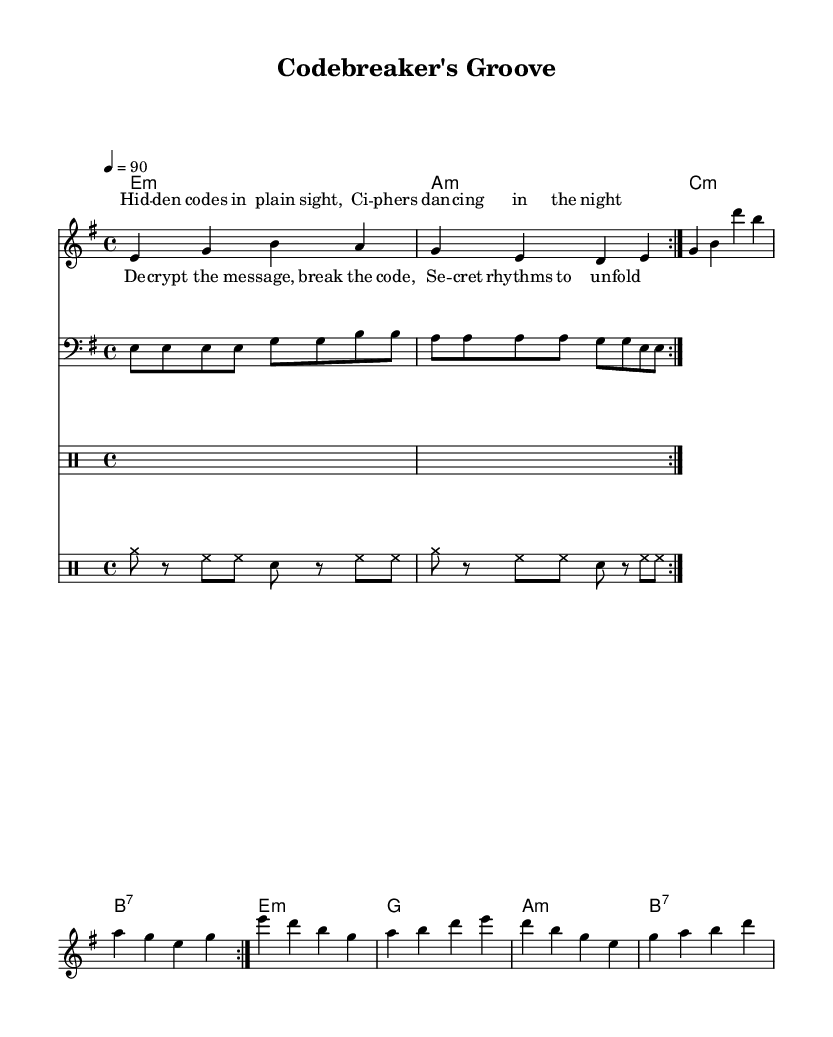What is the key signature of this music? The key signature is indicated at the beginning of the music, showing two sharps, which are F# and C#. This means the piece is in the key of E minor.
Answer: E minor What is the time signature of this music? The time signature is shown at the beginning of the music with a "4/4" notation, indicating that there are four beats in each measure and a quarter note receives one beat.
Answer: 4/4 What is the tempo marking of this music? The tempo marking is noted as "4 = 90," which indicates that the quarter note should be played at a speed of 90 beats per minute.
Answer: 90 How many times is the melody repeated in the piece? The melody has a "repeat volta 2" notation, which signifies that the melody is to be played twice through the first section, including the repeat signs.
Answer: 2 What is the main theme referenced in the lyrics of the verse? The lyrics in the verse refer to "hidden codes" and "cipher dancers," indicating a thematic focus on secrets and codes, typical of a mystery or cryptic message.
Answer: Hidden codes What chord appears most frequently in the harmony section? In the harmony section, the E minor chord is established as the starting and prominent chord, showing a particular significance in establishing the tonality. It reoccurs multiple times throughout the piece.
Answer: E minor Which musical element is predominantly used in the rhythm part? The rhythm part includes a repeating pattern of cymbals and hi-hat, which provides a steady and syncopated groove typical of rhythm and blues music, setting the foundation for the song's feel.
Answer: Cymbals 